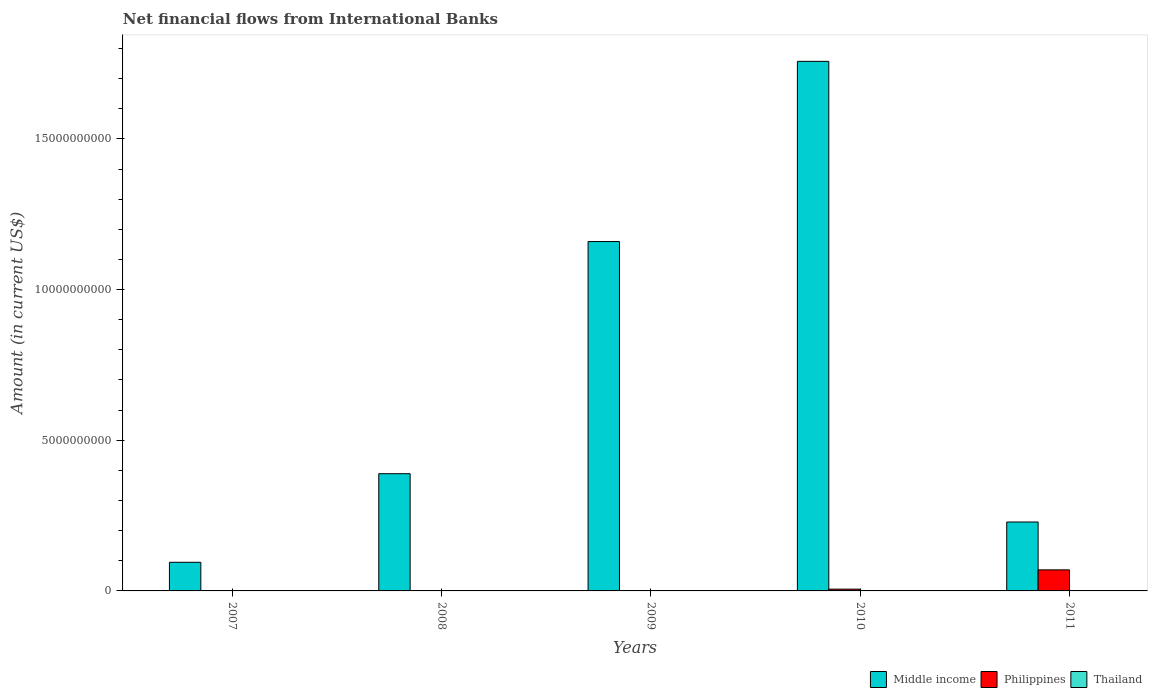How many different coloured bars are there?
Your answer should be very brief. 3. Are the number of bars on each tick of the X-axis equal?
Your answer should be very brief. No. How many bars are there on the 1st tick from the right?
Offer a terse response. 2. In how many cases, is the number of bars for a given year not equal to the number of legend labels?
Keep it short and to the point. 5. What is the net financial aid flows in Middle income in 2011?
Give a very brief answer. 2.29e+09. Across all years, what is the maximum net financial aid flows in Thailand?
Your response must be concise. 9.30e+06. Across all years, what is the minimum net financial aid flows in Philippines?
Your answer should be compact. 0. What is the total net financial aid flows in Philippines in the graph?
Your answer should be very brief. 7.58e+08. What is the difference between the net financial aid flows in Middle income in 2008 and that in 2009?
Provide a succinct answer. -7.70e+09. What is the difference between the net financial aid flows in Philippines in 2011 and the net financial aid flows in Thailand in 2008?
Give a very brief answer. 6.97e+08. What is the average net financial aid flows in Philippines per year?
Make the answer very short. 1.52e+08. In the year 2011, what is the difference between the net financial aid flows in Philippines and net financial aid flows in Middle income?
Your response must be concise. -1.59e+09. In how many years, is the net financial aid flows in Thailand greater than 15000000000 US$?
Your response must be concise. 0. What is the ratio of the net financial aid flows in Philippines in 2010 to that in 2011?
Offer a terse response. 0.08. Is the net financial aid flows in Middle income in 2008 less than that in 2011?
Your response must be concise. No. What is the difference between the highest and the second highest net financial aid flows in Middle income?
Ensure brevity in your answer.  5.98e+09. What is the difference between the highest and the lowest net financial aid flows in Thailand?
Make the answer very short. 9.30e+06. Is the sum of the net financial aid flows in Middle income in 2009 and 2010 greater than the maximum net financial aid flows in Philippines across all years?
Your answer should be very brief. Yes. Is it the case that in every year, the sum of the net financial aid flows in Middle income and net financial aid flows in Thailand is greater than the net financial aid flows in Philippines?
Provide a short and direct response. Yes. How many bars are there?
Give a very brief answer. 9. How many years are there in the graph?
Give a very brief answer. 5. Are the values on the major ticks of Y-axis written in scientific E-notation?
Make the answer very short. No. Does the graph contain any zero values?
Provide a short and direct response. Yes. What is the title of the graph?
Ensure brevity in your answer.  Net financial flows from International Banks. What is the label or title of the X-axis?
Your answer should be very brief. Years. What is the Amount (in current US$) of Middle income in 2007?
Your answer should be compact. 9.50e+08. What is the Amount (in current US$) in Middle income in 2008?
Your response must be concise. 3.89e+09. What is the Amount (in current US$) of Thailand in 2008?
Give a very brief answer. 1.63e+06. What is the Amount (in current US$) in Middle income in 2009?
Make the answer very short. 1.16e+1. What is the Amount (in current US$) in Thailand in 2009?
Offer a very short reply. 9.30e+06. What is the Amount (in current US$) in Middle income in 2010?
Provide a short and direct response. 1.76e+1. What is the Amount (in current US$) of Philippines in 2010?
Provide a succinct answer. 5.89e+07. What is the Amount (in current US$) of Thailand in 2010?
Ensure brevity in your answer.  0. What is the Amount (in current US$) in Middle income in 2011?
Offer a terse response. 2.29e+09. What is the Amount (in current US$) of Philippines in 2011?
Give a very brief answer. 6.99e+08. What is the Amount (in current US$) in Thailand in 2011?
Ensure brevity in your answer.  0. Across all years, what is the maximum Amount (in current US$) in Middle income?
Provide a short and direct response. 1.76e+1. Across all years, what is the maximum Amount (in current US$) of Philippines?
Ensure brevity in your answer.  6.99e+08. Across all years, what is the maximum Amount (in current US$) in Thailand?
Keep it short and to the point. 9.30e+06. Across all years, what is the minimum Amount (in current US$) in Middle income?
Keep it short and to the point. 9.50e+08. What is the total Amount (in current US$) in Middle income in the graph?
Make the answer very short. 3.63e+1. What is the total Amount (in current US$) of Philippines in the graph?
Offer a very short reply. 7.58e+08. What is the total Amount (in current US$) in Thailand in the graph?
Offer a very short reply. 1.09e+07. What is the difference between the Amount (in current US$) of Middle income in 2007 and that in 2008?
Provide a short and direct response. -2.94e+09. What is the difference between the Amount (in current US$) in Middle income in 2007 and that in 2009?
Provide a short and direct response. -1.06e+1. What is the difference between the Amount (in current US$) in Middle income in 2007 and that in 2010?
Provide a short and direct response. -1.66e+1. What is the difference between the Amount (in current US$) in Middle income in 2007 and that in 2011?
Offer a terse response. -1.34e+09. What is the difference between the Amount (in current US$) in Middle income in 2008 and that in 2009?
Keep it short and to the point. -7.70e+09. What is the difference between the Amount (in current US$) in Thailand in 2008 and that in 2009?
Give a very brief answer. -7.67e+06. What is the difference between the Amount (in current US$) in Middle income in 2008 and that in 2010?
Provide a short and direct response. -1.37e+1. What is the difference between the Amount (in current US$) of Middle income in 2008 and that in 2011?
Offer a very short reply. 1.60e+09. What is the difference between the Amount (in current US$) of Middle income in 2009 and that in 2010?
Your response must be concise. -5.98e+09. What is the difference between the Amount (in current US$) in Middle income in 2009 and that in 2011?
Your answer should be very brief. 9.31e+09. What is the difference between the Amount (in current US$) of Middle income in 2010 and that in 2011?
Offer a very short reply. 1.53e+1. What is the difference between the Amount (in current US$) of Philippines in 2010 and that in 2011?
Offer a terse response. -6.40e+08. What is the difference between the Amount (in current US$) in Middle income in 2007 and the Amount (in current US$) in Thailand in 2008?
Provide a succinct answer. 9.49e+08. What is the difference between the Amount (in current US$) in Middle income in 2007 and the Amount (in current US$) in Thailand in 2009?
Your response must be concise. 9.41e+08. What is the difference between the Amount (in current US$) of Middle income in 2007 and the Amount (in current US$) of Philippines in 2010?
Provide a succinct answer. 8.91e+08. What is the difference between the Amount (in current US$) in Middle income in 2007 and the Amount (in current US$) in Philippines in 2011?
Offer a terse response. 2.52e+08. What is the difference between the Amount (in current US$) of Middle income in 2008 and the Amount (in current US$) of Thailand in 2009?
Give a very brief answer. 3.88e+09. What is the difference between the Amount (in current US$) of Middle income in 2008 and the Amount (in current US$) of Philippines in 2010?
Ensure brevity in your answer.  3.83e+09. What is the difference between the Amount (in current US$) in Middle income in 2008 and the Amount (in current US$) in Philippines in 2011?
Your answer should be very brief. 3.19e+09. What is the difference between the Amount (in current US$) in Middle income in 2009 and the Amount (in current US$) in Philippines in 2010?
Offer a very short reply. 1.15e+1. What is the difference between the Amount (in current US$) of Middle income in 2009 and the Amount (in current US$) of Philippines in 2011?
Make the answer very short. 1.09e+1. What is the difference between the Amount (in current US$) of Middle income in 2010 and the Amount (in current US$) of Philippines in 2011?
Give a very brief answer. 1.69e+1. What is the average Amount (in current US$) of Middle income per year?
Offer a terse response. 7.26e+09. What is the average Amount (in current US$) of Philippines per year?
Provide a succinct answer. 1.52e+08. What is the average Amount (in current US$) of Thailand per year?
Your answer should be very brief. 2.19e+06. In the year 2008, what is the difference between the Amount (in current US$) of Middle income and Amount (in current US$) of Thailand?
Provide a succinct answer. 3.89e+09. In the year 2009, what is the difference between the Amount (in current US$) of Middle income and Amount (in current US$) of Thailand?
Offer a very short reply. 1.16e+1. In the year 2010, what is the difference between the Amount (in current US$) in Middle income and Amount (in current US$) in Philippines?
Your response must be concise. 1.75e+1. In the year 2011, what is the difference between the Amount (in current US$) of Middle income and Amount (in current US$) of Philippines?
Ensure brevity in your answer.  1.59e+09. What is the ratio of the Amount (in current US$) in Middle income in 2007 to that in 2008?
Your answer should be compact. 0.24. What is the ratio of the Amount (in current US$) of Middle income in 2007 to that in 2009?
Your response must be concise. 0.08. What is the ratio of the Amount (in current US$) in Middle income in 2007 to that in 2010?
Your answer should be compact. 0.05. What is the ratio of the Amount (in current US$) of Middle income in 2007 to that in 2011?
Make the answer very short. 0.42. What is the ratio of the Amount (in current US$) of Middle income in 2008 to that in 2009?
Keep it short and to the point. 0.34. What is the ratio of the Amount (in current US$) of Thailand in 2008 to that in 2009?
Your answer should be compact. 0.18. What is the ratio of the Amount (in current US$) in Middle income in 2008 to that in 2010?
Provide a succinct answer. 0.22. What is the ratio of the Amount (in current US$) in Middle income in 2008 to that in 2011?
Provide a short and direct response. 1.7. What is the ratio of the Amount (in current US$) of Middle income in 2009 to that in 2010?
Ensure brevity in your answer.  0.66. What is the ratio of the Amount (in current US$) of Middle income in 2009 to that in 2011?
Provide a short and direct response. 5.07. What is the ratio of the Amount (in current US$) in Middle income in 2010 to that in 2011?
Make the answer very short. 7.68. What is the ratio of the Amount (in current US$) of Philippines in 2010 to that in 2011?
Your answer should be very brief. 0.08. What is the difference between the highest and the second highest Amount (in current US$) of Middle income?
Offer a terse response. 5.98e+09. What is the difference between the highest and the lowest Amount (in current US$) in Middle income?
Offer a very short reply. 1.66e+1. What is the difference between the highest and the lowest Amount (in current US$) in Philippines?
Keep it short and to the point. 6.99e+08. What is the difference between the highest and the lowest Amount (in current US$) in Thailand?
Provide a succinct answer. 9.30e+06. 